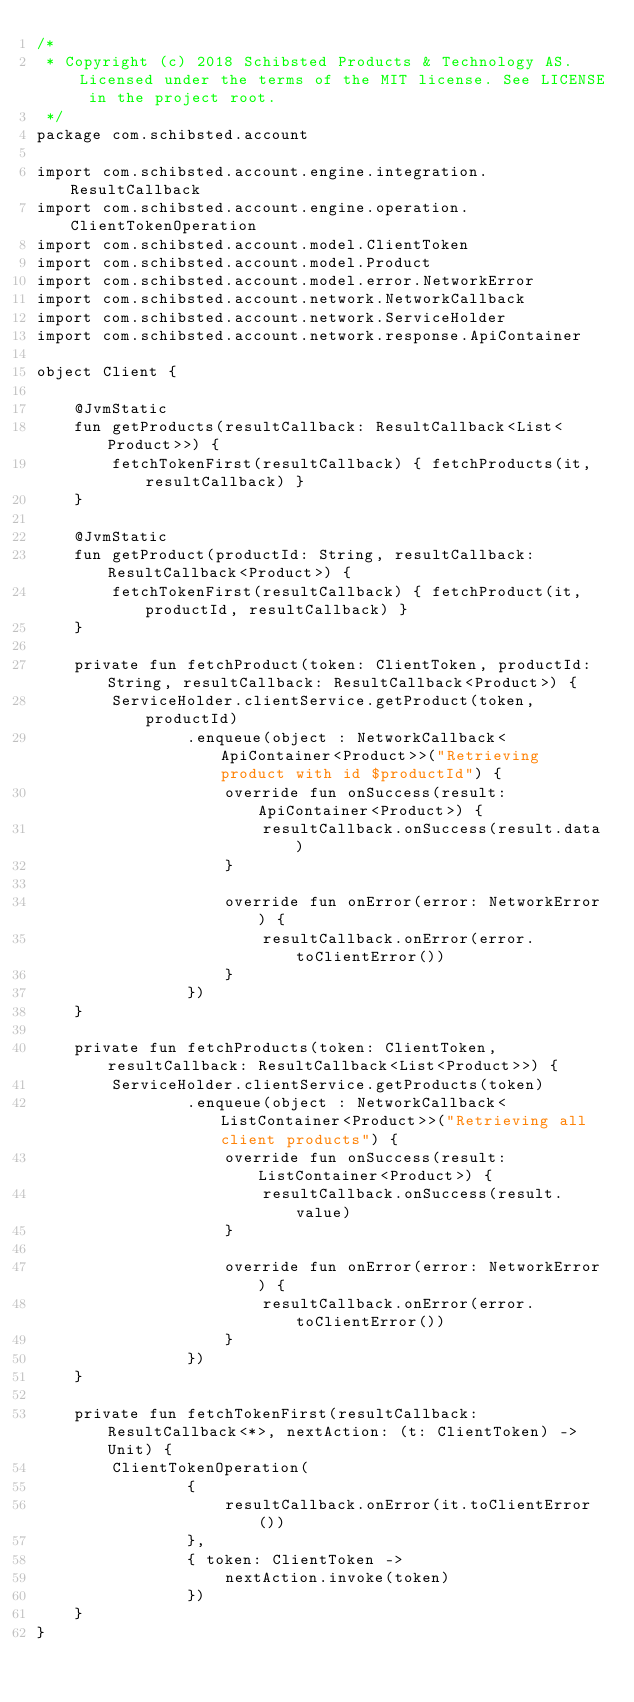<code> <loc_0><loc_0><loc_500><loc_500><_Kotlin_>/*
 * Copyright (c) 2018 Schibsted Products & Technology AS. Licensed under the terms of the MIT license. See LICENSE in the project root.
 */
package com.schibsted.account

import com.schibsted.account.engine.integration.ResultCallback
import com.schibsted.account.engine.operation.ClientTokenOperation
import com.schibsted.account.model.ClientToken
import com.schibsted.account.model.Product
import com.schibsted.account.model.error.NetworkError
import com.schibsted.account.network.NetworkCallback
import com.schibsted.account.network.ServiceHolder
import com.schibsted.account.network.response.ApiContainer

object Client {

    @JvmStatic
    fun getProducts(resultCallback: ResultCallback<List<Product>>) {
        fetchTokenFirst(resultCallback) { fetchProducts(it, resultCallback) }
    }

    @JvmStatic
    fun getProduct(productId: String, resultCallback: ResultCallback<Product>) {
        fetchTokenFirst(resultCallback) { fetchProduct(it, productId, resultCallback) }
    }

    private fun fetchProduct(token: ClientToken, productId: String, resultCallback: ResultCallback<Product>) {
        ServiceHolder.clientService.getProduct(token, productId)
                .enqueue(object : NetworkCallback<ApiContainer<Product>>("Retrieving product with id $productId") {
                    override fun onSuccess(result: ApiContainer<Product>) {
                        resultCallback.onSuccess(result.data)
                    }

                    override fun onError(error: NetworkError) {
                        resultCallback.onError(error.toClientError())
                    }
                })
    }

    private fun fetchProducts(token: ClientToken, resultCallback: ResultCallback<List<Product>>) {
        ServiceHolder.clientService.getProducts(token)
                .enqueue(object : NetworkCallback<ListContainer<Product>>("Retrieving all client products") {
                    override fun onSuccess(result: ListContainer<Product>) {
                        resultCallback.onSuccess(result.value)
                    }

                    override fun onError(error: NetworkError) {
                        resultCallback.onError(error.toClientError())
                    }
                })
    }

    private fun fetchTokenFirst(resultCallback: ResultCallback<*>, nextAction: (t: ClientToken) -> Unit) {
        ClientTokenOperation(
                {
                    resultCallback.onError(it.toClientError())
                },
                { token: ClientToken ->
                    nextAction.invoke(token)
                })
    }
}</code> 